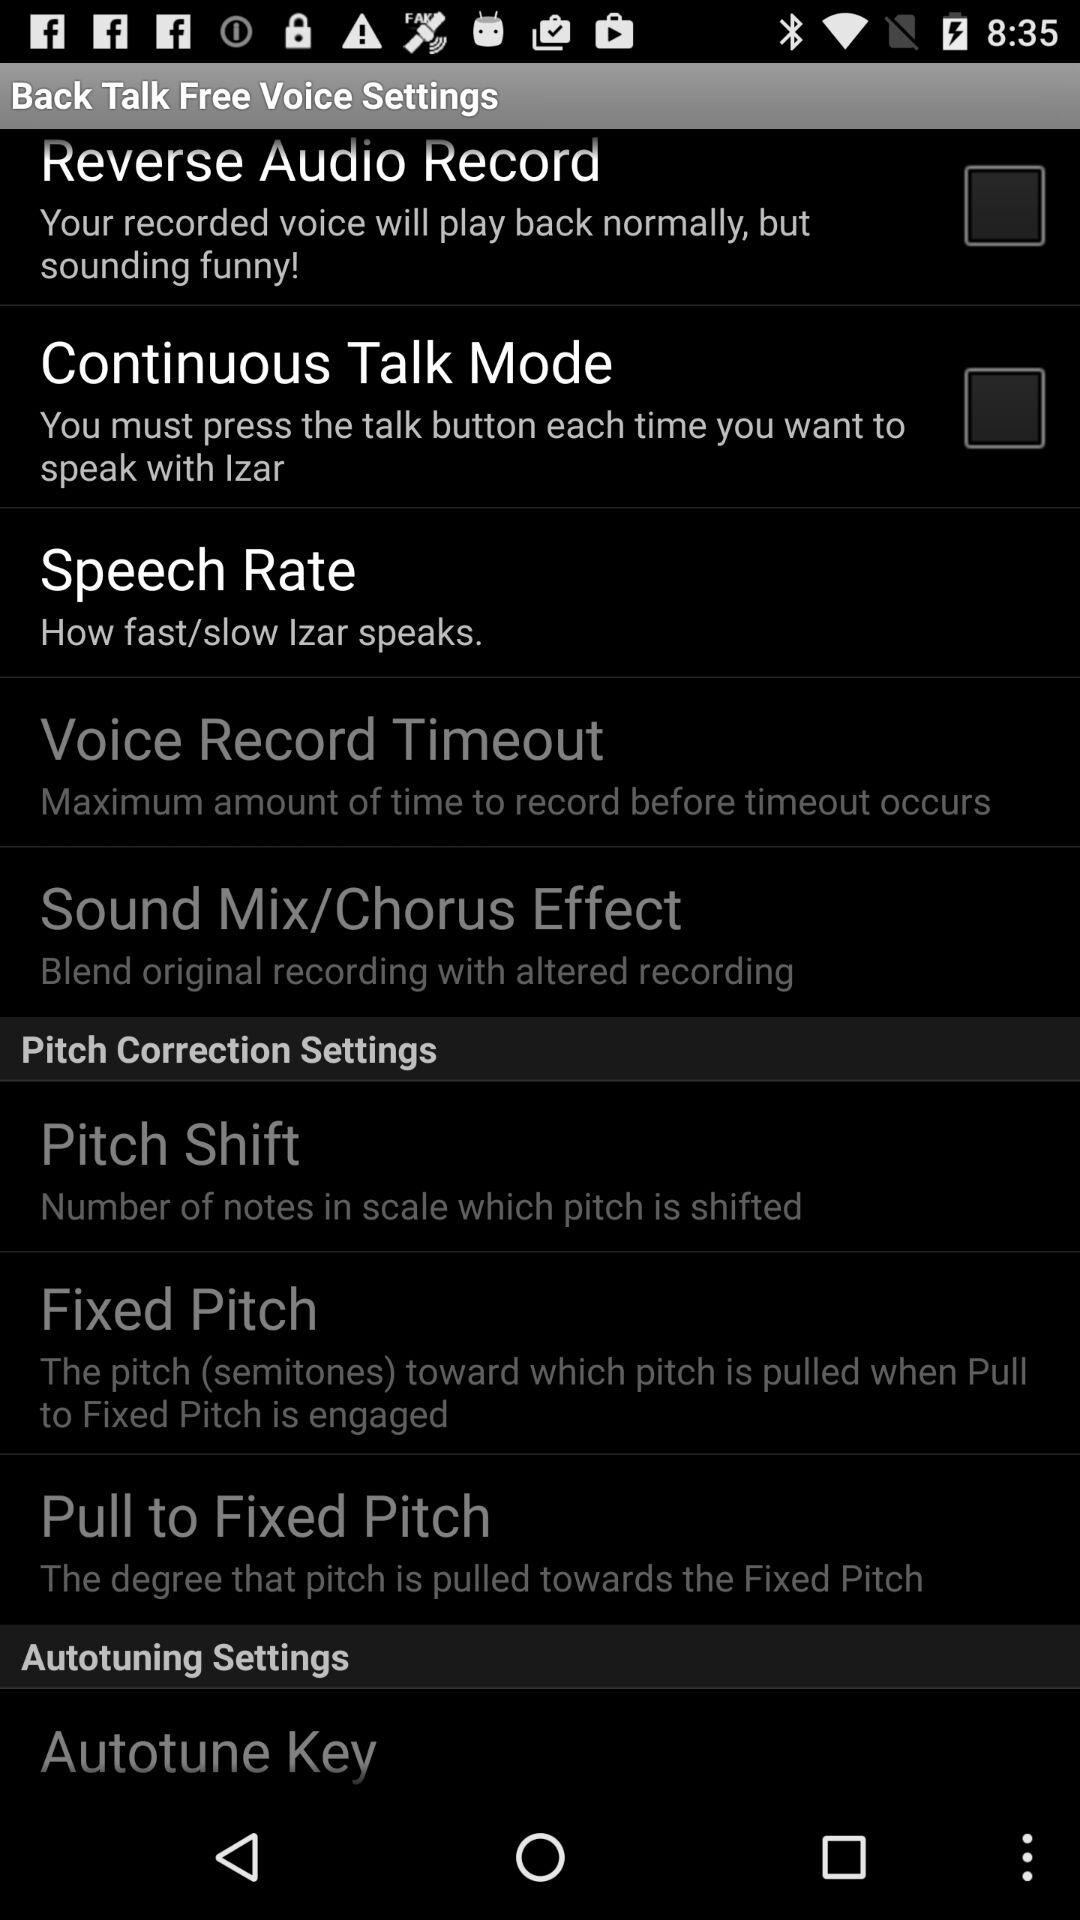What is the status of "Continuous Talk Mode"? The status is "off". 